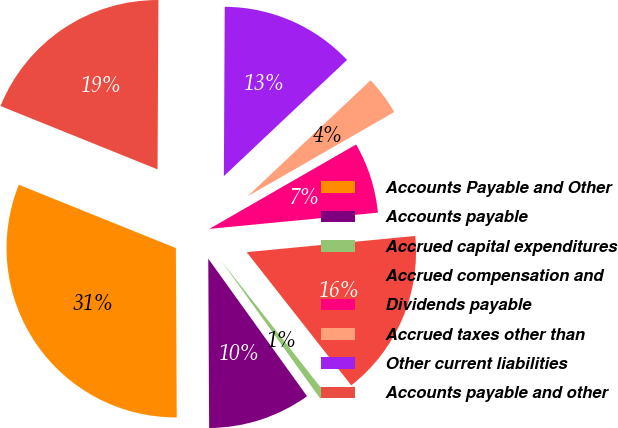Convert chart to OTSL. <chart><loc_0><loc_0><loc_500><loc_500><pie_chart><fcel>Accounts Payable and Other<fcel>Accounts payable<fcel>Accrued capital expenditures<fcel>Accrued compensation and<fcel>Dividends payable<fcel>Accrued taxes other than<fcel>Other current liabilities<fcel>Accounts payable and other<nl><fcel>31.18%<fcel>9.83%<fcel>0.68%<fcel>15.93%<fcel>6.78%<fcel>3.73%<fcel>12.88%<fcel>18.98%<nl></chart> 